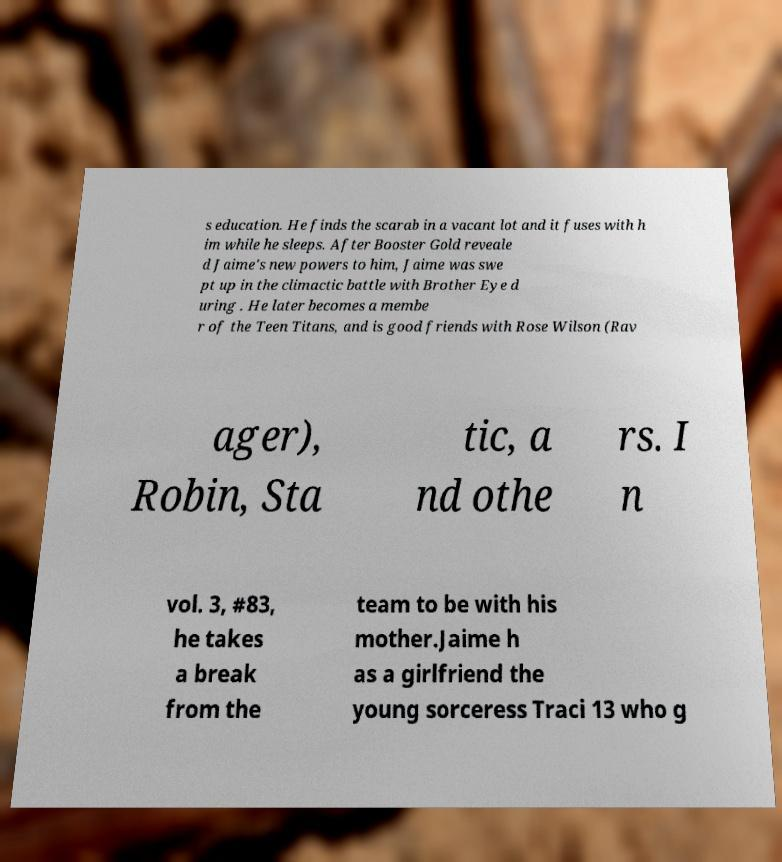What messages or text are displayed in this image? I need them in a readable, typed format. s education. He finds the scarab in a vacant lot and it fuses with h im while he sleeps. After Booster Gold reveale d Jaime's new powers to him, Jaime was swe pt up in the climactic battle with Brother Eye d uring . He later becomes a membe r of the Teen Titans, and is good friends with Rose Wilson (Rav ager), Robin, Sta tic, a nd othe rs. I n vol. 3, #83, he takes a break from the team to be with his mother.Jaime h as a girlfriend the young sorceress Traci 13 who g 